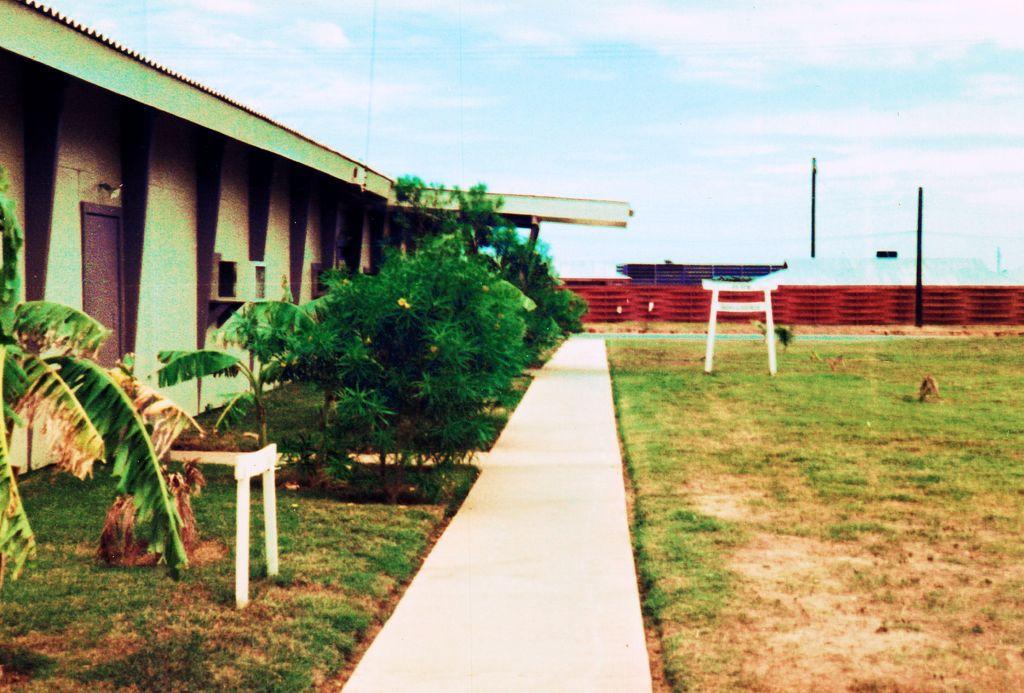Can you describe this image briefly? In this image I can see a ground , on the left side I can see building and trees and bench and in the background I can see the sky and wall, pole. 